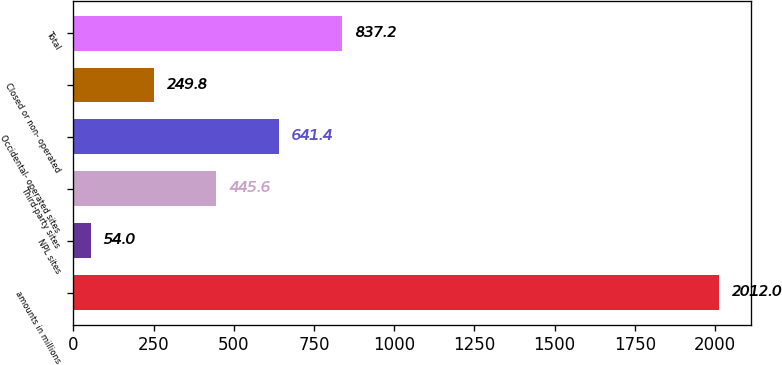Convert chart to OTSL. <chart><loc_0><loc_0><loc_500><loc_500><bar_chart><fcel>amounts in millions<fcel>NPL sites<fcel>Third-party sites<fcel>Occidental- operated sites<fcel>Closed or non- operated<fcel>Total<nl><fcel>2012<fcel>54<fcel>445.6<fcel>641.4<fcel>249.8<fcel>837.2<nl></chart> 